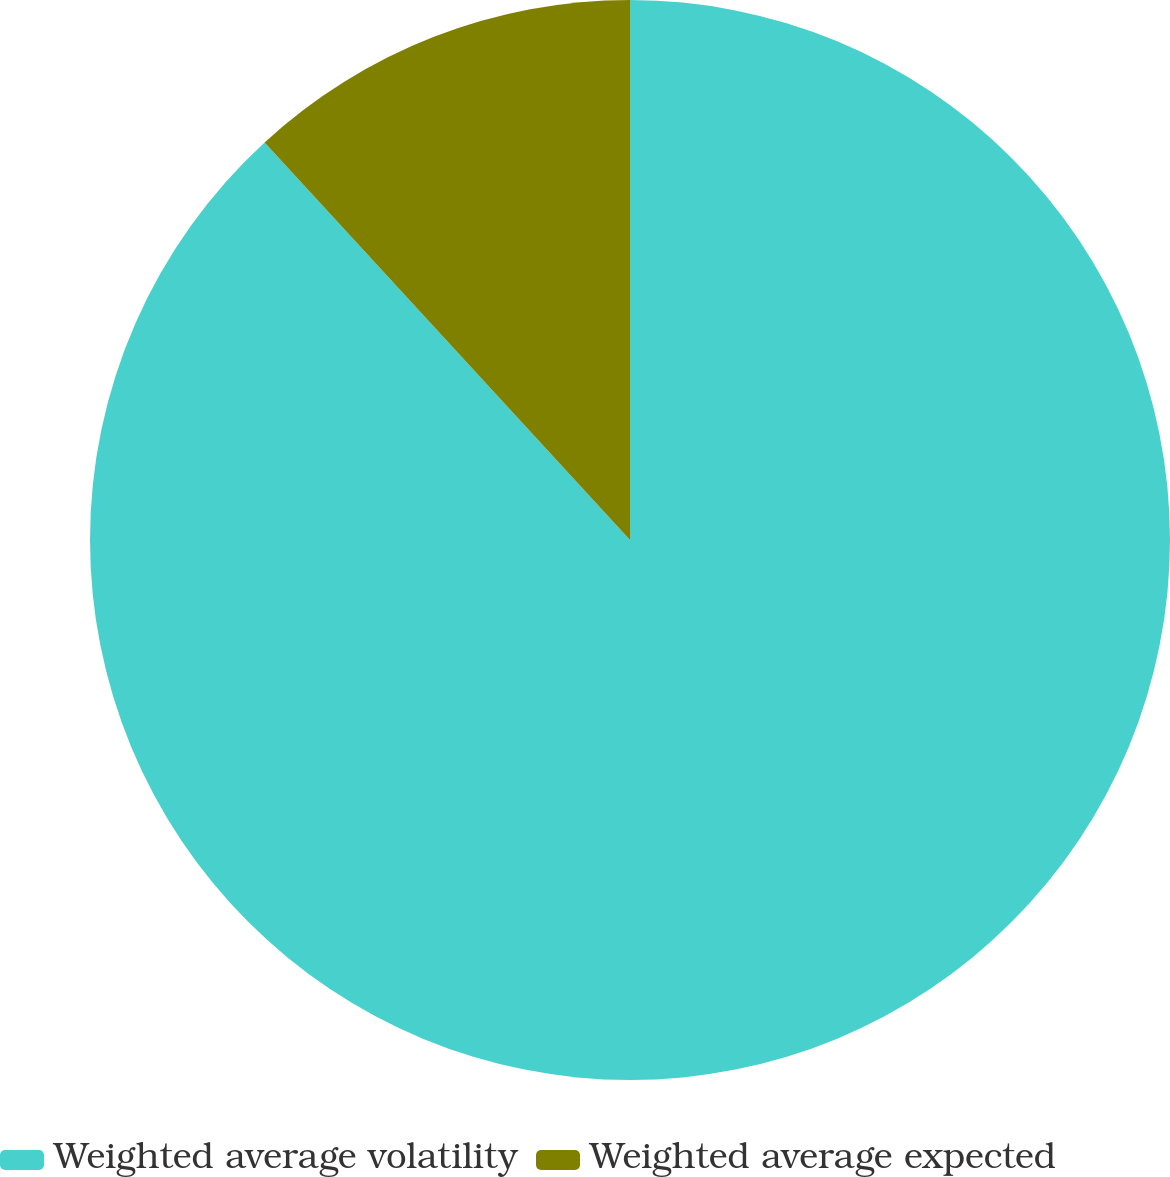Convert chart to OTSL. <chart><loc_0><loc_0><loc_500><loc_500><pie_chart><fcel>Weighted average volatility<fcel>Weighted average expected<nl><fcel>88.17%<fcel>11.83%<nl></chart> 